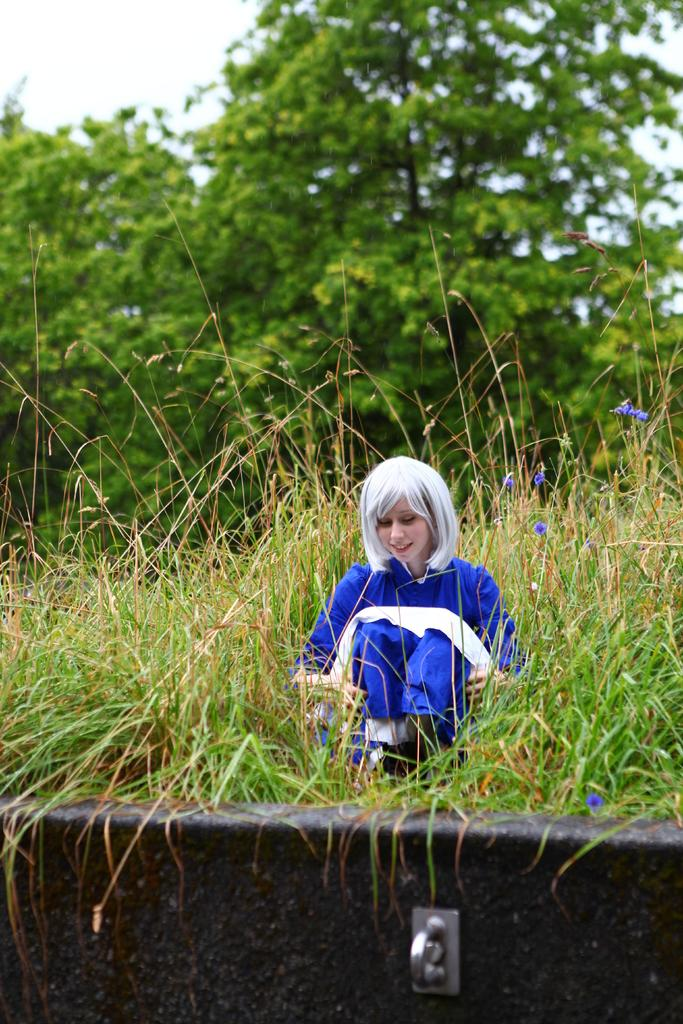Who is present in the image? There is a woman in the image. What is the woman wearing? The woman is wearing a blue dress. Where is the woman sitting? The woman is sitting on the grass. What can be seen in the background of the image? There are plants with blue flowers, trees, and the sky visible in the background of the image. Are there any babies playing with the volcano in the image? There is no volcano or babies present in the image. 